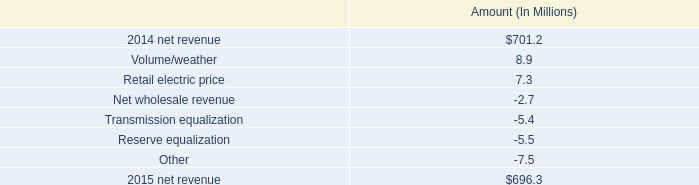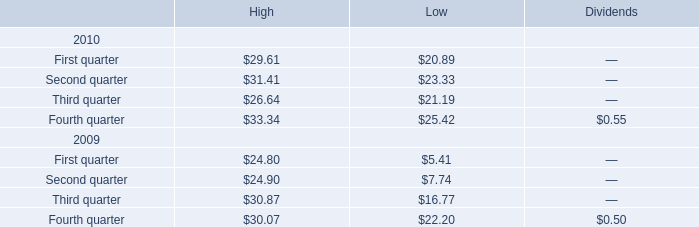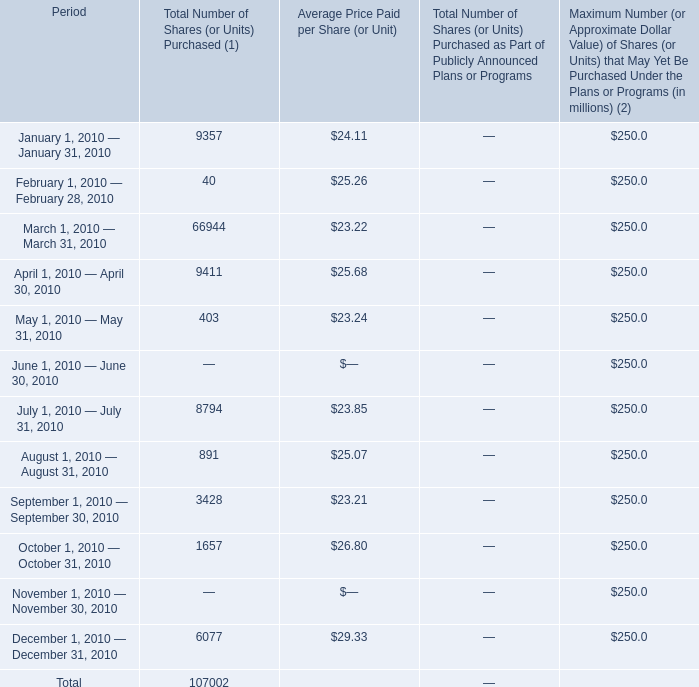What is the sum of the Average Price Paid per Share (or Unit) for Period May 1, 2010 — May 31, 2010? 
Answer: 23.24. 